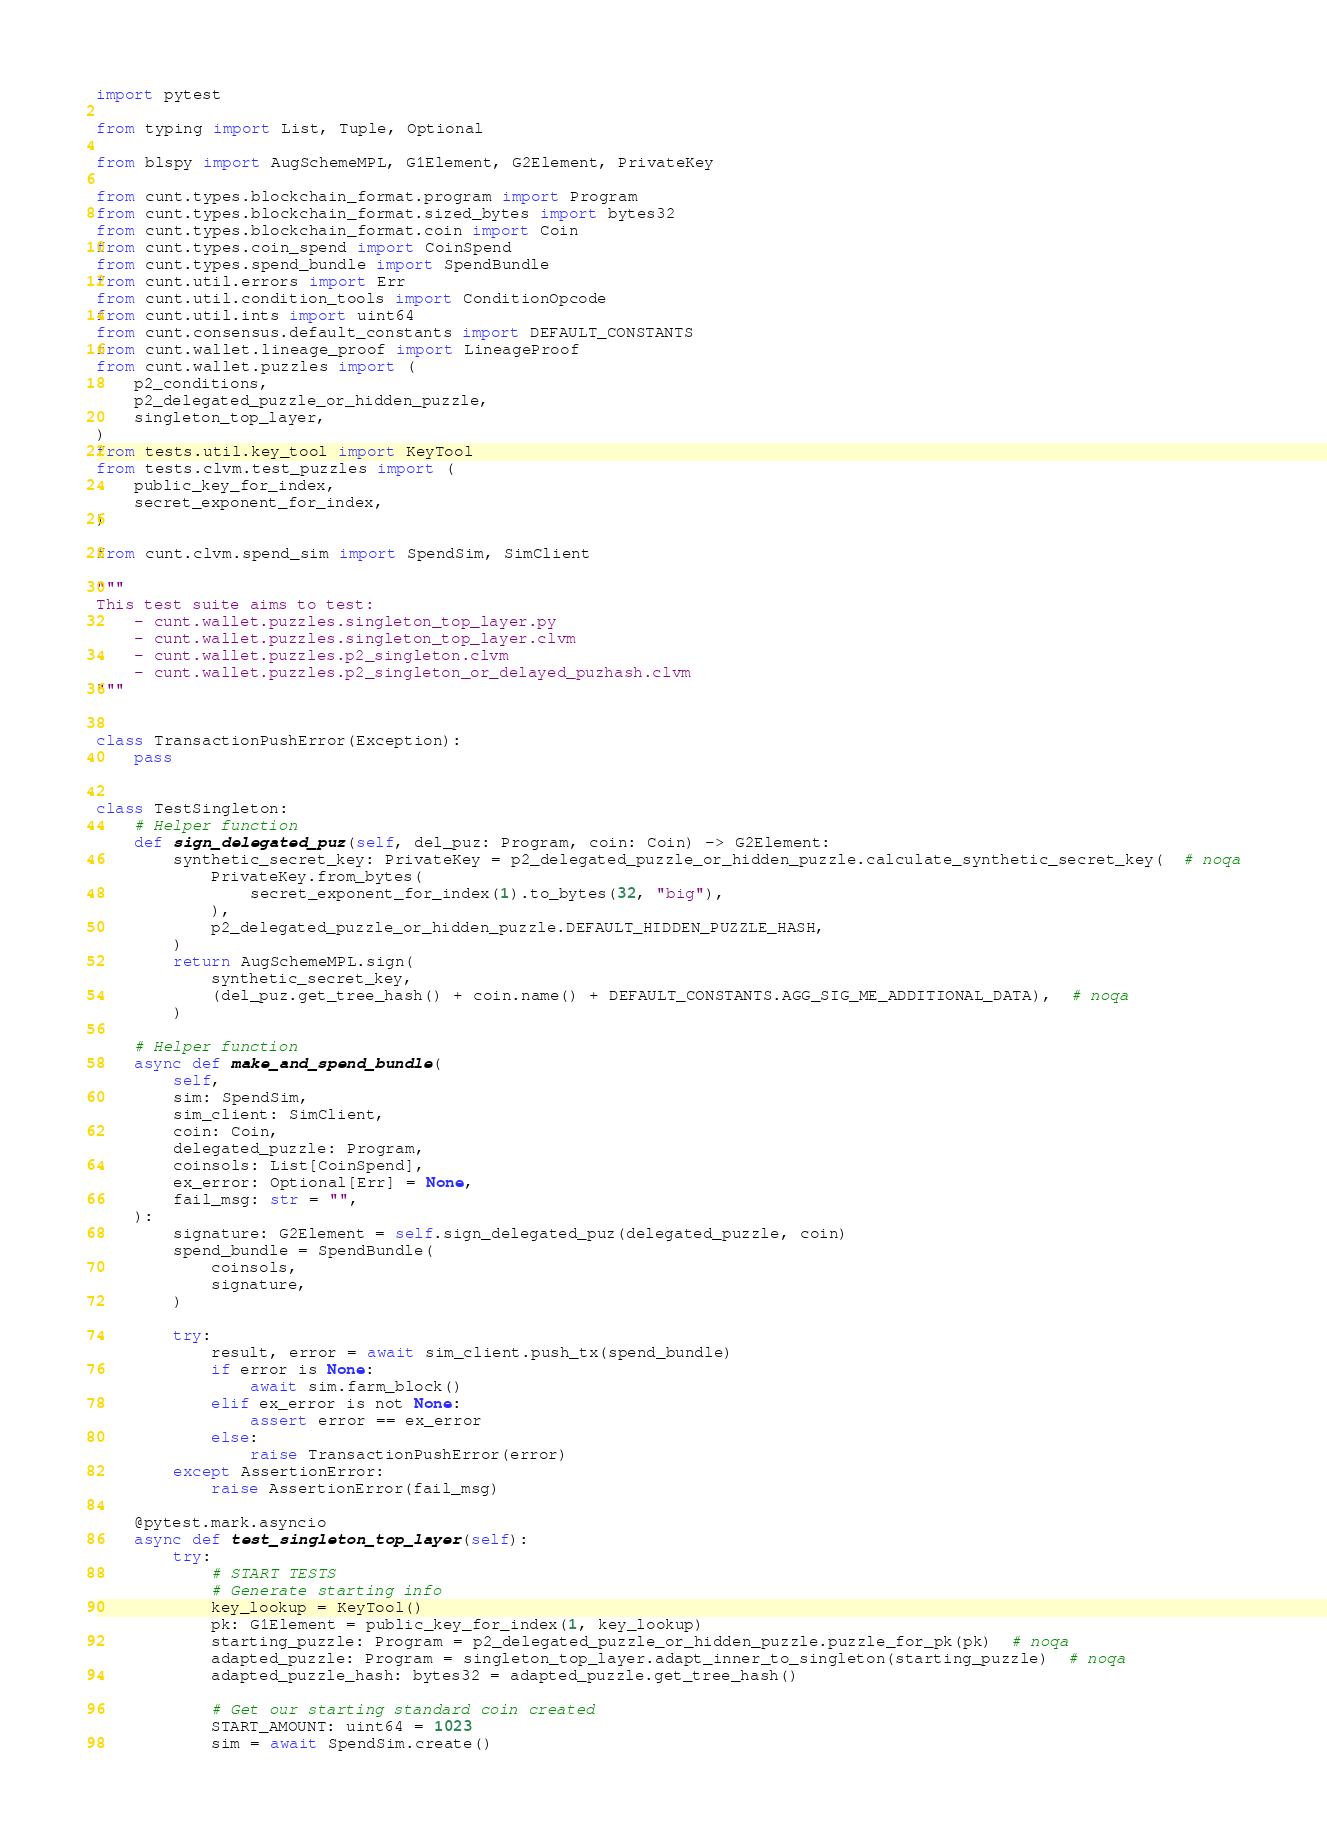<code> <loc_0><loc_0><loc_500><loc_500><_Python_>import pytest

from typing import List, Tuple, Optional

from blspy import AugSchemeMPL, G1Element, G2Element, PrivateKey

from cunt.types.blockchain_format.program import Program
from cunt.types.blockchain_format.sized_bytes import bytes32
from cunt.types.blockchain_format.coin import Coin
from cunt.types.coin_spend import CoinSpend
from cunt.types.spend_bundle import SpendBundle
from cunt.util.errors import Err
from cunt.util.condition_tools import ConditionOpcode
from cunt.util.ints import uint64
from cunt.consensus.default_constants import DEFAULT_CONSTANTS
from cunt.wallet.lineage_proof import LineageProof
from cunt.wallet.puzzles import (
    p2_conditions,
    p2_delegated_puzzle_or_hidden_puzzle,
    singleton_top_layer,
)
from tests.util.key_tool import KeyTool
from tests.clvm.test_puzzles import (
    public_key_for_index,
    secret_exponent_for_index,
)

from cunt.clvm.spend_sim import SpendSim, SimClient

"""
This test suite aims to test:
    - cunt.wallet.puzzles.singleton_top_layer.py
    - cunt.wallet.puzzles.singleton_top_layer.clvm
    - cunt.wallet.puzzles.p2_singleton.clvm
    - cunt.wallet.puzzles.p2_singleton_or_delayed_puzhash.clvm
"""


class TransactionPushError(Exception):
    pass


class TestSingleton:
    # Helper function
    def sign_delegated_puz(self, del_puz: Program, coin: Coin) -> G2Element:
        synthetic_secret_key: PrivateKey = p2_delegated_puzzle_or_hidden_puzzle.calculate_synthetic_secret_key(  # noqa
            PrivateKey.from_bytes(
                secret_exponent_for_index(1).to_bytes(32, "big"),
            ),
            p2_delegated_puzzle_or_hidden_puzzle.DEFAULT_HIDDEN_PUZZLE_HASH,
        )
        return AugSchemeMPL.sign(
            synthetic_secret_key,
            (del_puz.get_tree_hash() + coin.name() + DEFAULT_CONSTANTS.AGG_SIG_ME_ADDITIONAL_DATA),  # noqa
        )

    # Helper function
    async def make_and_spend_bundle(
        self,
        sim: SpendSim,
        sim_client: SimClient,
        coin: Coin,
        delegated_puzzle: Program,
        coinsols: List[CoinSpend],
        ex_error: Optional[Err] = None,
        fail_msg: str = "",
    ):
        signature: G2Element = self.sign_delegated_puz(delegated_puzzle, coin)
        spend_bundle = SpendBundle(
            coinsols,
            signature,
        )

        try:
            result, error = await sim_client.push_tx(spend_bundle)
            if error is None:
                await sim.farm_block()
            elif ex_error is not None:
                assert error == ex_error
            else:
                raise TransactionPushError(error)
        except AssertionError:
            raise AssertionError(fail_msg)

    @pytest.mark.asyncio
    async def test_singleton_top_layer(self):
        try:
            # START TESTS
            # Generate starting info
            key_lookup = KeyTool()
            pk: G1Element = public_key_for_index(1, key_lookup)
            starting_puzzle: Program = p2_delegated_puzzle_or_hidden_puzzle.puzzle_for_pk(pk)  # noqa
            adapted_puzzle: Program = singleton_top_layer.adapt_inner_to_singleton(starting_puzzle)  # noqa
            adapted_puzzle_hash: bytes32 = adapted_puzzle.get_tree_hash()

            # Get our starting standard coin created
            START_AMOUNT: uint64 = 1023
            sim = await SpendSim.create()</code> 